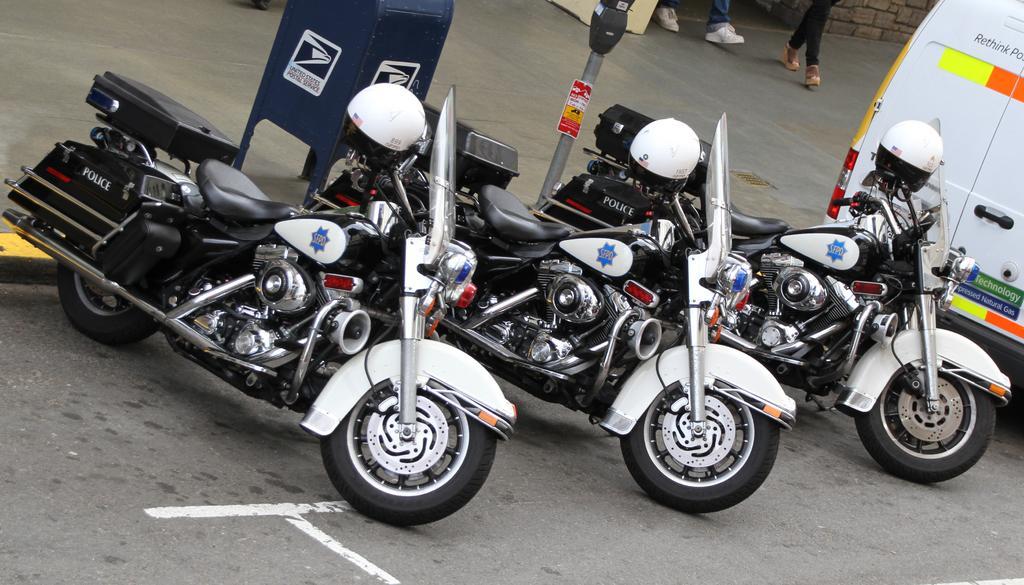Could you give a brief overview of what you see in this image? In this image I see 3 bikes which are of white and black in color and I see white color helmets on it and I see a word written on 3 bikes and I see a van over here and I can also see there are words written on it and I see the road. In the background I see the pole, 2 persons legs over here and I see the blue color thing on this footpath. 